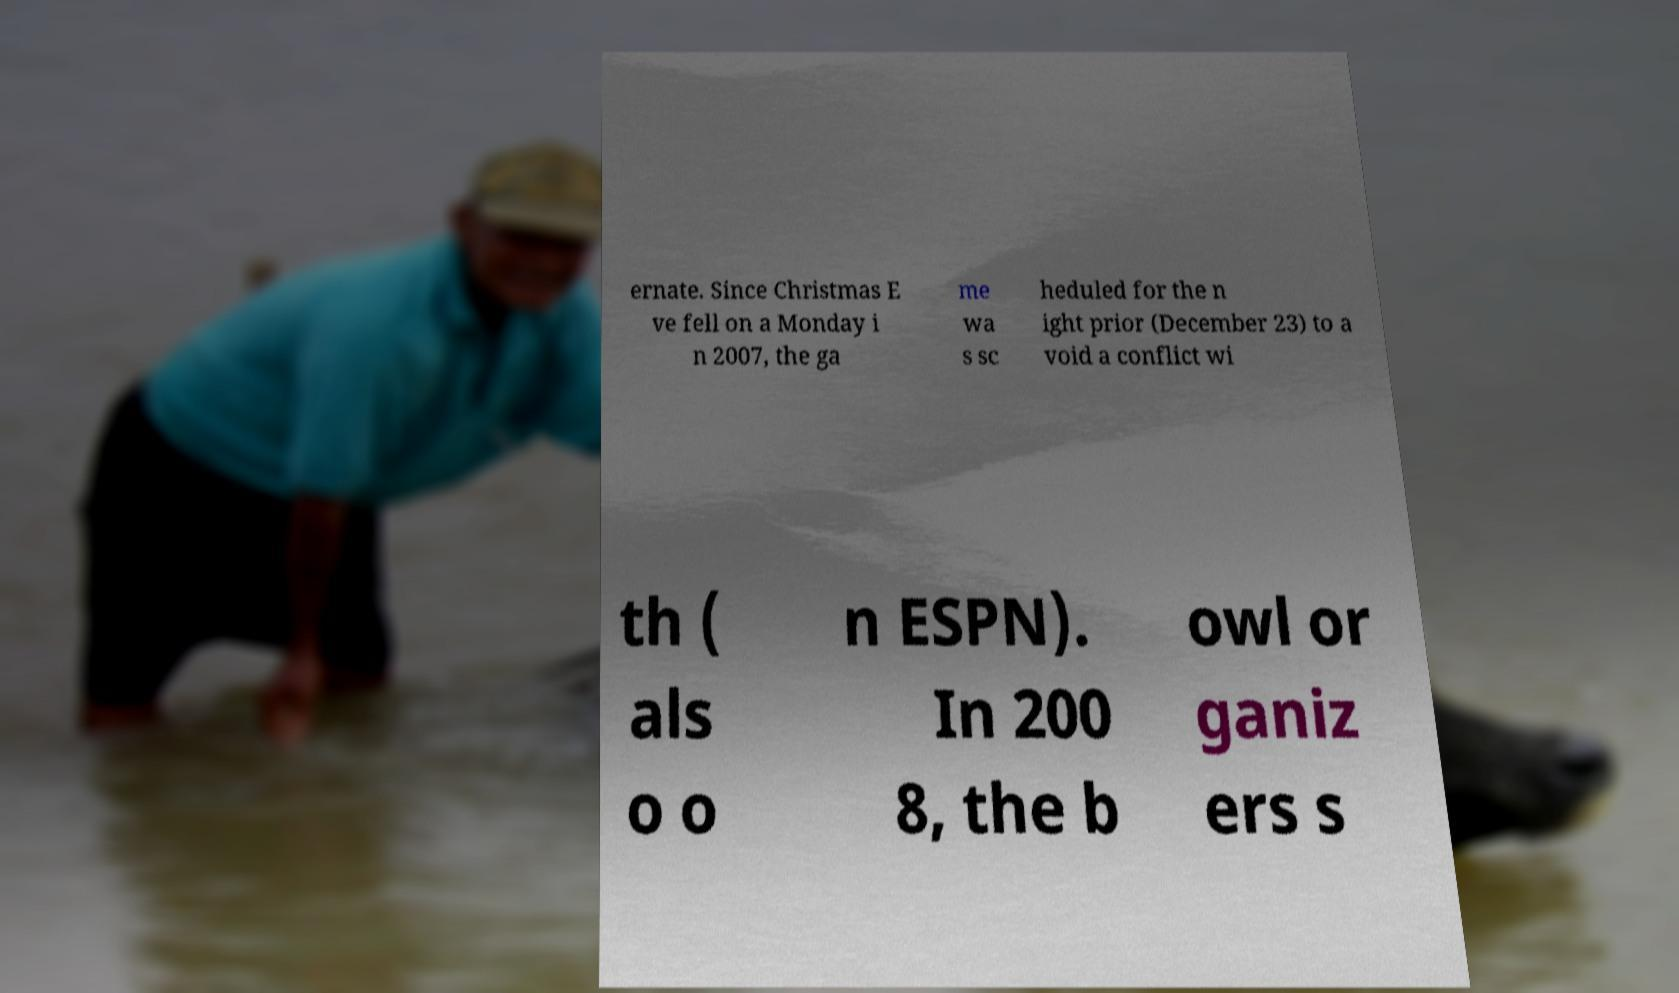Could you assist in decoding the text presented in this image and type it out clearly? ernate. Since Christmas E ve fell on a Monday i n 2007, the ga me wa s sc heduled for the n ight prior (December 23) to a void a conflict wi th ( als o o n ESPN). In 200 8, the b owl or ganiz ers s 